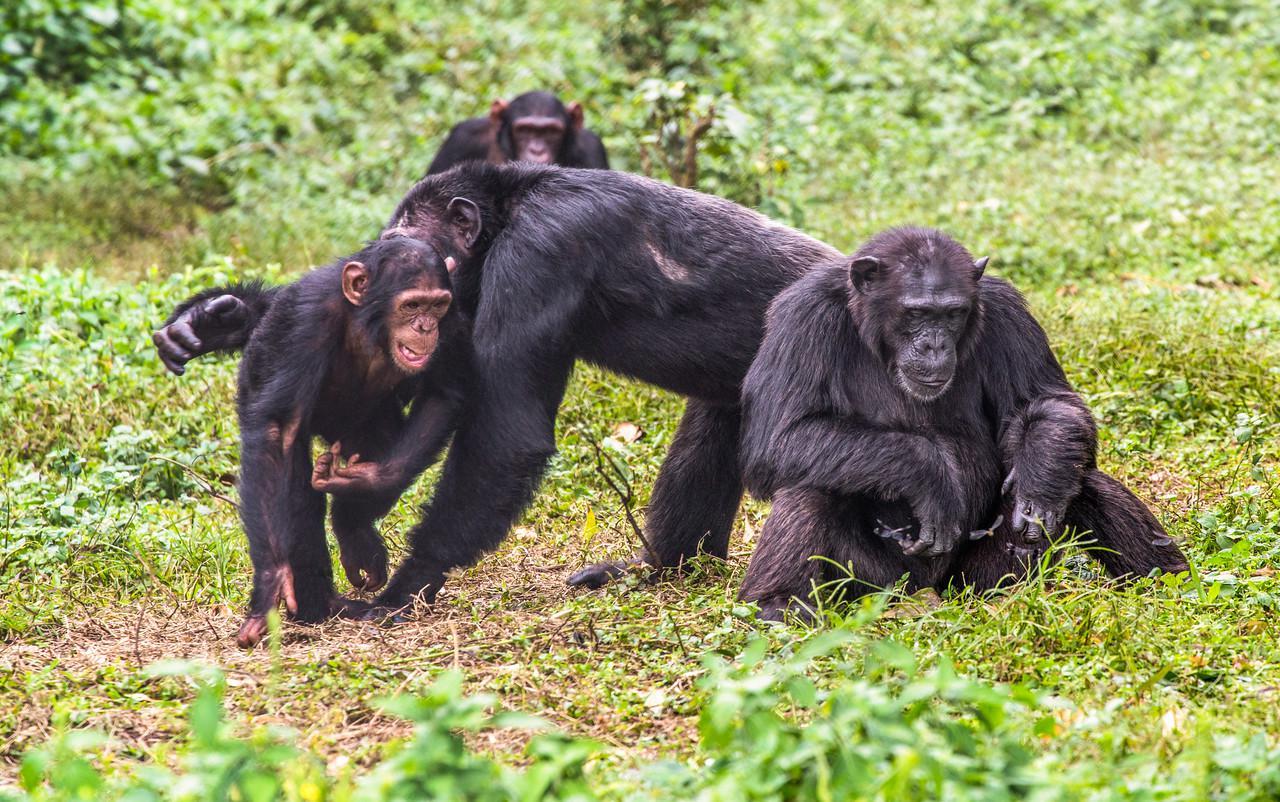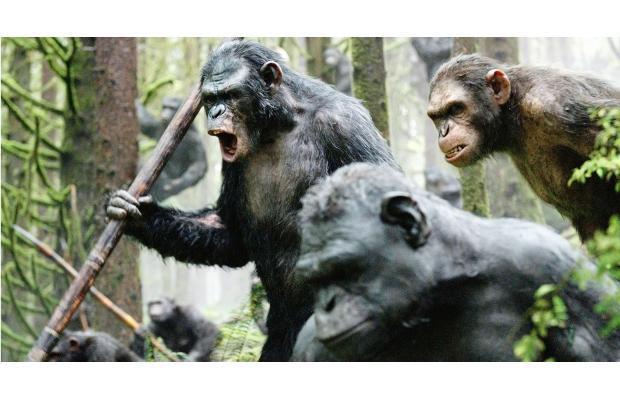The first image is the image on the left, the second image is the image on the right. Assess this claim about the two images: "At least one of the primates is on its hind legs.". Correct or not? Answer yes or no. Yes. The first image is the image on the left, the second image is the image on the right. For the images shown, is this caption "The left image shows a group of three apes, with a fourth ape in the background." true? Answer yes or no. Yes. 